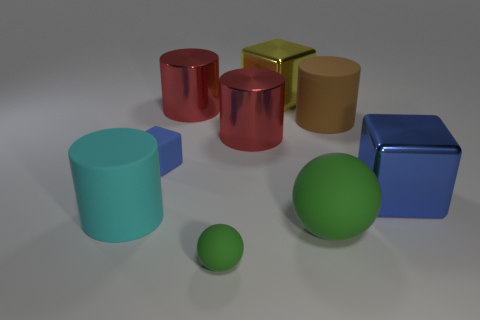What material is the big thing that is the same color as the tiny rubber sphere?
Your response must be concise. Rubber. What color is the cube that is made of the same material as the tiny green object?
Keep it short and to the point. Blue. There is a brown object; how many small blue cubes are in front of it?
Provide a short and direct response. 1. There is a small thing that is in front of the large cyan matte cylinder; is it the same color as the large ball that is in front of the small blue rubber cube?
Give a very brief answer. Yes. There is another rubber thing that is the same shape as the brown matte thing; what is its color?
Ensure brevity in your answer.  Cyan. Do the big matte thing behind the rubber cube and the tiny rubber object in front of the large blue metallic object have the same shape?
Give a very brief answer. No. There is a blue metal cube; is its size the same as the cylinder that is in front of the matte cube?
Give a very brief answer. Yes. Are there more large metal things than big rubber cylinders?
Provide a succinct answer. Yes. Is the material of the blue object on the right side of the big yellow thing the same as the big object left of the blue rubber cube?
Your response must be concise. No. What is the small block made of?
Keep it short and to the point. Rubber. 